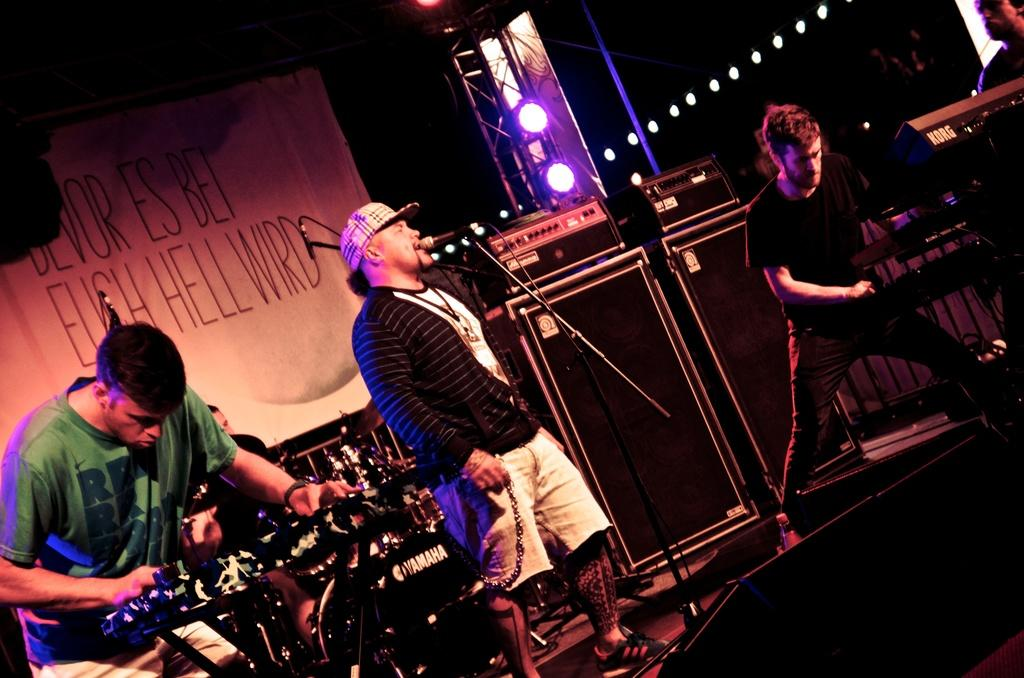What are the people on stage doing? The people on stage are playing musical instruments. What is the man with the microphone doing? The man is singing on a microphone. What can be seen hanging in the image? There is a banner in the image. What is used to amplify the sound in the image? There are speakers in the image. What can be seen in the background of the image? The background of the image includes lights. What type of jewel is the man wearing on his forehead while singing? There is no jewel visible on the man's forehead in the image. How does the man show respect to the audience while singing? The image does not show any specific actions related to respect; it only shows the man singing on a microphone. 